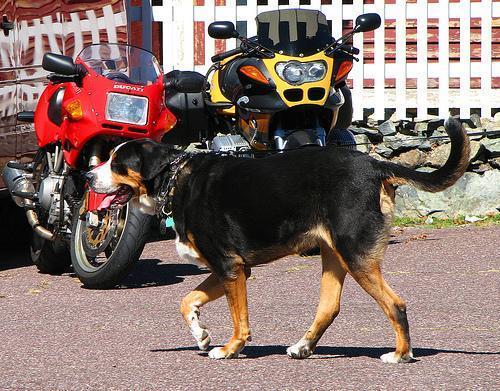How many dogs are in this picture?
Give a very brief answer. 1. 